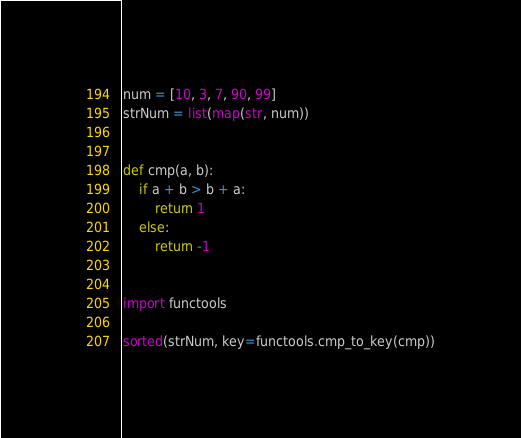Convert code to text. <code><loc_0><loc_0><loc_500><loc_500><_Python_>num = [10, 3, 7, 90, 99]
strNum = list(map(str, num))


def cmp(a, b):
    if a + b > b + a:
        return 1
    else:
        return -1


import functools

sorted(strNum, key=functools.cmp_to_key(cmp))
</code> 